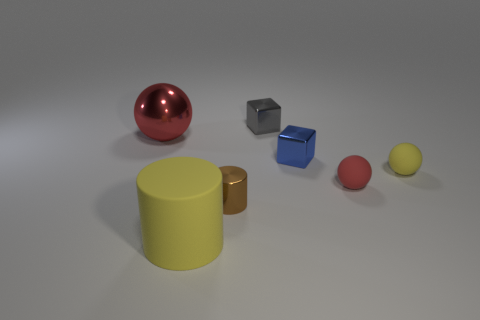Subtract all purple cylinders. How many red balls are left? 2 Subtract all large balls. How many balls are left? 2 Add 3 small yellow matte objects. How many objects exist? 10 Subtract all spheres. How many objects are left? 4 Subtract all cyan balls. Subtract all brown blocks. How many balls are left? 3 Subtract all blue matte objects. Subtract all tiny red things. How many objects are left? 6 Add 4 small objects. How many small objects are left? 9 Add 5 big rubber objects. How many big rubber objects exist? 6 Subtract 0 red cylinders. How many objects are left? 7 